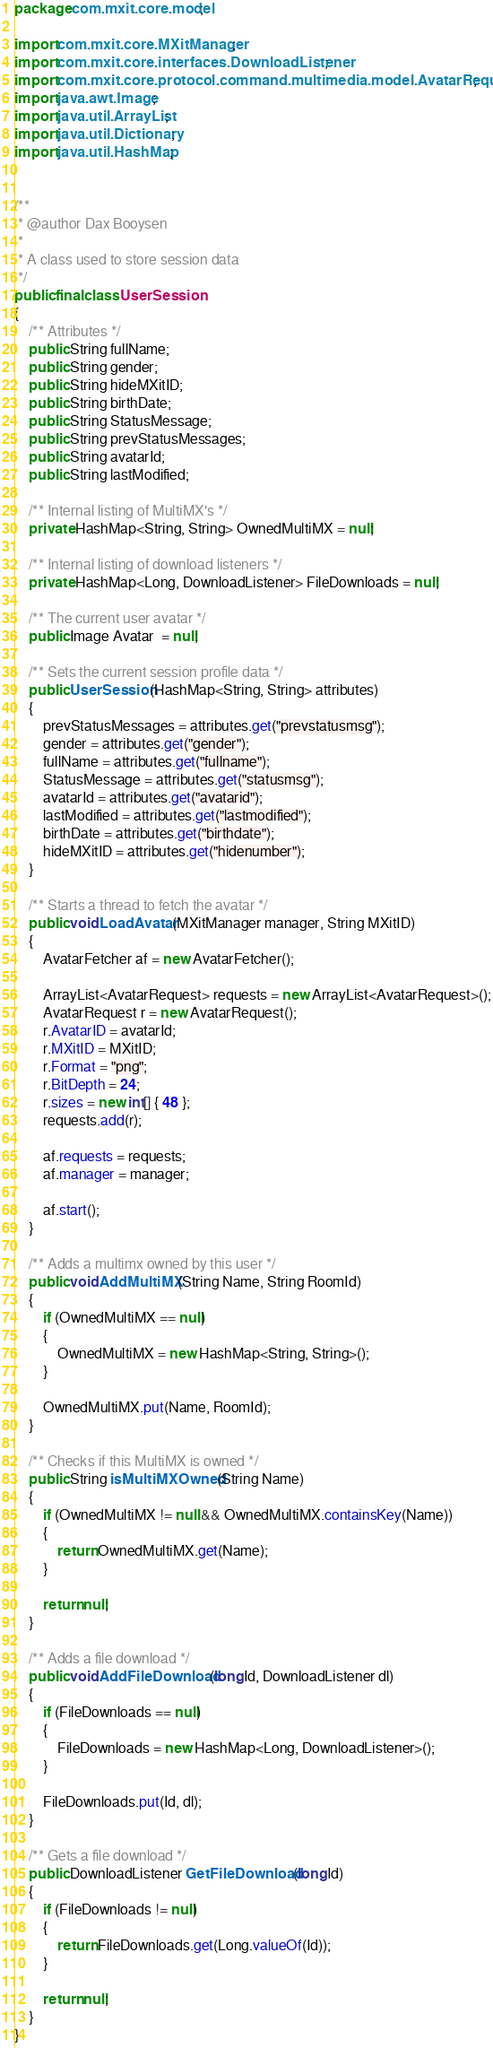Convert code to text. <code><loc_0><loc_0><loc_500><loc_500><_Java_>package com.mxit.core.model;

import com.mxit.core.MXitManager;
import com.mxit.core.interfaces.DownloadListener;
import com.mxit.core.protocol.command.multimedia.model.AvatarRequest;
import java.awt.Image;
import java.util.ArrayList;
import java.util.Dictionary;
import java.util.HashMap;


/**
 * @author Dax Booysen
 *
 * A class used to store session data
 */
public final class UserSession
{
    /** Attributes */
    public String fullName;
    public String gender;
    public String hideMXitID;
    public String birthDate;
    public String StatusMessage;
    public String prevStatusMessages;
    public String avatarId;
    public String lastModified;

    /** Internal listing of MultiMX's */
    private HashMap<String, String> OwnedMultiMX = null;

    /** Internal listing of download listeners */
    private HashMap<Long, DownloadListener> FileDownloads = null;

    /** The current user avatar */
    public Image Avatar  = null;

    /** Sets the current session profile data */
    public UserSession(HashMap<String, String> attributes)
    {
        prevStatusMessages = attributes.get("prevstatusmsg");
        gender = attributes.get("gender");
        fullName = attributes.get("fullname");
        StatusMessage = attributes.get("statusmsg");
        avatarId = attributes.get("avatarid");
        lastModified = attributes.get("lastmodified");
        birthDate = attributes.get("birthdate");
        hideMXitID = attributes.get("hidenumber");
    }

    /** Starts a thread to fetch the avatar */
    public void LoadAvatar(MXitManager manager, String MXitID)
    {
        AvatarFetcher af = new AvatarFetcher();

        ArrayList<AvatarRequest> requests = new ArrayList<AvatarRequest>();
        AvatarRequest r = new AvatarRequest();
        r.AvatarID = avatarId;
        r.MXitID = MXitID;
        r.Format = "png";
        r.BitDepth = 24;
        r.sizes = new int[] { 48 };
        requests.add(r);

        af.requests = requests;
        af.manager = manager;

        af.start();
    }

    /** Adds a multimx owned by this user */
    public void AddMultiMX(String Name, String RoomId)
    {
        if (OwnedMultiMX == null)
        {
            OwnedMultiMX = new HashMap<String, String>();
        }

        OwnedMultiMX.put(Name, RoomId);
    }

    /** Checks if this MultiMX is owned */
    public String isMultiMXOwned(String Name)
    {
        if (OwnedMultiMX != null && OwnedMultiMX.containsKey(Name))
        {
            return OwnedMultiMX.get(Name);
        }

        return null;
    }

    /** Adds a file download */
    public void AddFileDownload(long Id, DownloadListener dl)
    {
        if (FileDownloads == null)
        {
            FileDownloads = new HashMap<Long, DownloadListener>();
        }

        FileDownloads.put(Id, dl);
    }

    /** Gets a file download */
    public DownloadListener GetFileDownload(long Id)
    {
        if (FileDownloads != null)
        {
            return FileDownloads.get(Long.valueOf(Id));
        }

        return null;
    }
}

</code> 